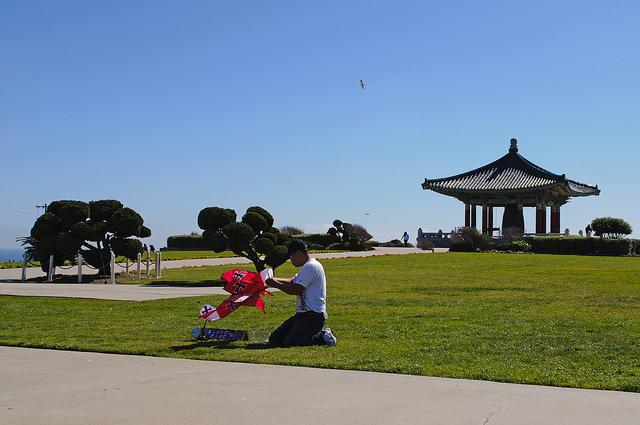What is the man kneeling going to do next?

Choices:
A) play tennis
B) fly kite
C) go swimming
D) race cars fly kite 